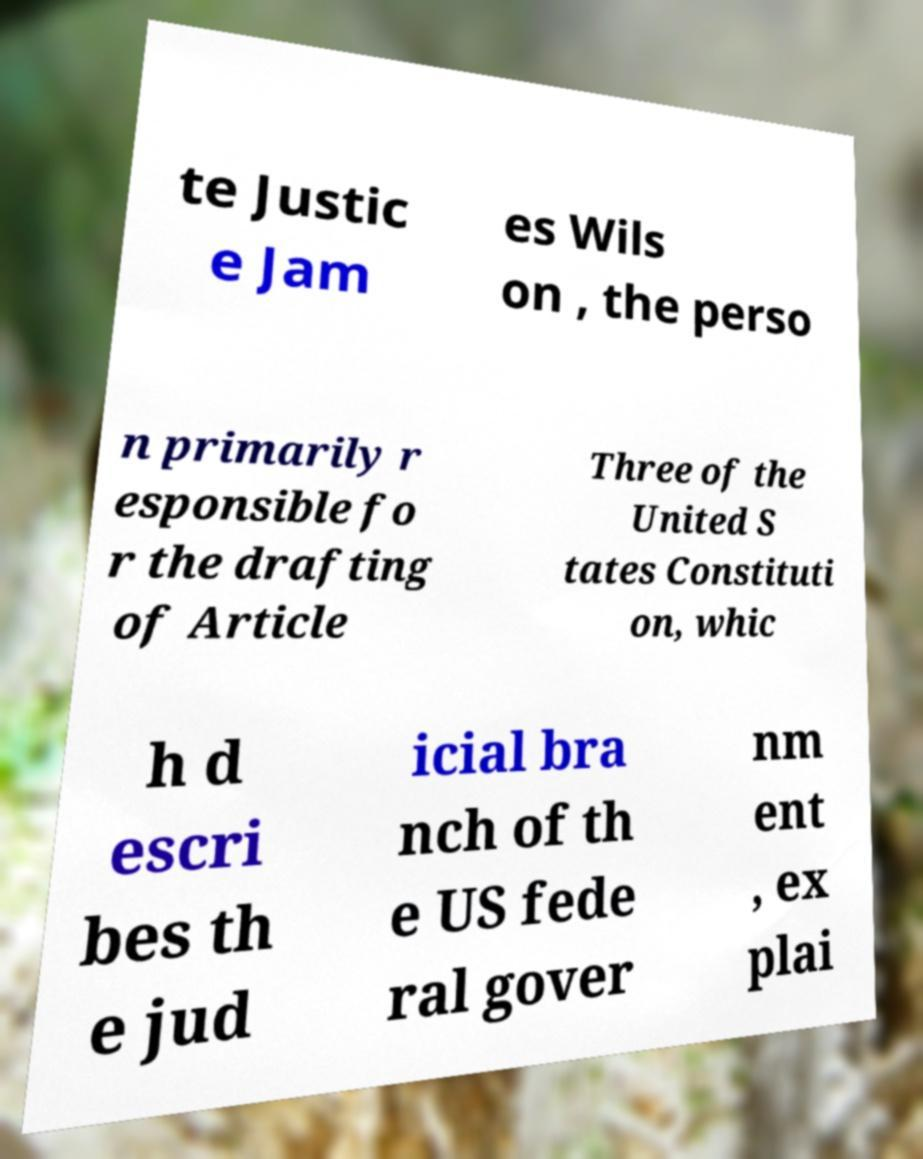Please read and relay the text visible in this image. What does it say? te Justic e Jam es Wils on , the perso n primarily r esponsible fo r the drafting of Article Three of the United S tates Constituti on, whic h d escri bes th e jud icial bra nch of th e US fede ral gover nm ent , ex plai 